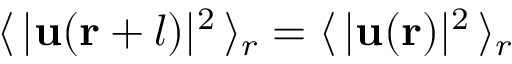Convert formula to latex. <formula><loc_0><loc_0><loc_500><loc_500>\langle \, | u ( r + l ) | ^ { 2 } \, \rangle _ { r } = \langle \, | u ( r ) | ^ { 2 } \, \rangle _ { r }</formula> 